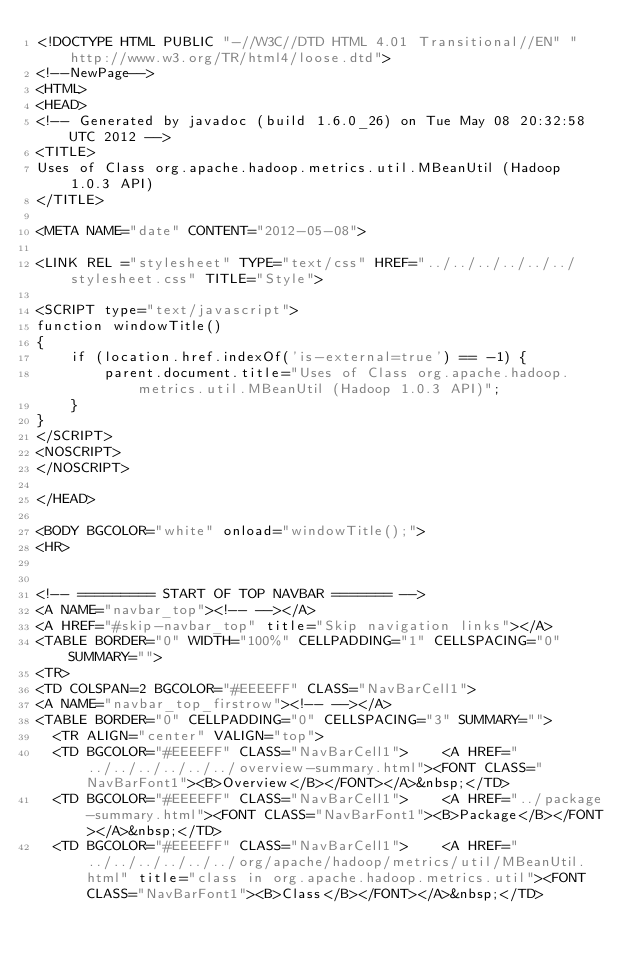Convert code to text. <code><loc_0><loc_0><loc_500><loc_500><_HTML_><!DOCTYPE HTML PUBLIC "-//W3C//DTD HTML 4.01 Transitional//EN" "http://www.w3.org/TR/html4/loose.dtd">
<!--NewPage-->
<HTML>
<HEAD>
<!-- Generated by javadoc (build 1.6.0_26) on Tue May 08 20:32:58 UTC 2012 -->
<TITLE>
Uses of Class org.apache.hadoop.metrics.util.MBeanUtil (Hadoop 1.0.3 API)
</TITLE>

<META NAME="date" CONTENT="2012-05-08">

<LINK REL ="stylesheet" TYPE="text/css" HREF="../../../../../../stylesheet.css" TITLE="Style">

<SCRIPT type="text/javascript">
function windowTitle()
{
    if (location.href.indexOf('is-external=true') == -1) {
        parent.document.title="Uses of Class org.apache.hadoop.metrics.util.MBeanUtil (Hadoop 1.0.3 API)";
    }
}
</SCRIPT>
<NOSCRIPT>
</NOSCRIPT>

</HEAD>

<BODY BGCOLOR="white" onload="windowTitle();">
<HR>


<!-- ========= START OF TOP NAVBAR ======= -->
<A NAME="navbar_top"><!-- --></A>
<A HREF="#skip-navbar_top" title="Skip navigation links"></A>
<TABLE BORDER="0" WIDTH="100%" CELLPADDING="1" CELLSPACING="0" SUMMARY="">
<TR>
<TD COLSPAN=2 BGCOLOR="#EEEEFF" CLASS="NavBarCell1">
<A NAME="navbar_top_firstrow"><!-- --></A>
<TABLE BORDER="0" CELLPADDING="0" CELLSPACING="3" SUMMARY="">
  <TR ALIGN="center" VALIGN="top">
  <TD BGCOLOR="#EEEEFF" CLASS="NavBarCell1">    <A HREF="../../../../../../overview-summary.html"><FONT CLASS="NavBarFont1"><B>Overview</B></FONT></A>&nbsp;</TD>
  <TD BGCOLOR="#EEEEFF" CLASS="NavBarCell1">    <A HREF="../package-summary.html"><FONT CLASS="NavBarFont1"><B>Package</B></FONT></A>&nbsp;</TD>
  <TD BGCOLOR="#EEEEFF" CLASS="NavBarCell1">    <A HREF="../../../../../../org/apache/hadoop/metrics/util/MBeanUtil.html" title="class in org.apache.hadoop.metrics.util"><FONT CLASS="NavBarFont1"><B>Class</B></FONT></A>&nbsp;</TD></code> 